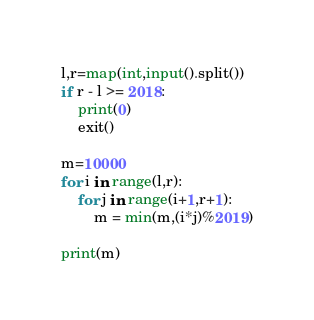Convert code to text. <code><loc_0><loc_0><loc_500><loc_500><_Python_>l,r=map(int,input().split())
if r - l >= 2018:
    print(0)
    exit()

m=10000
for i in range(l,r):
    for j in range(i+1,r+1):
        m = min(m,(i*j)%2019)

print(m)</code> 